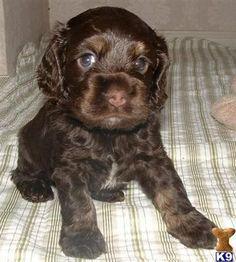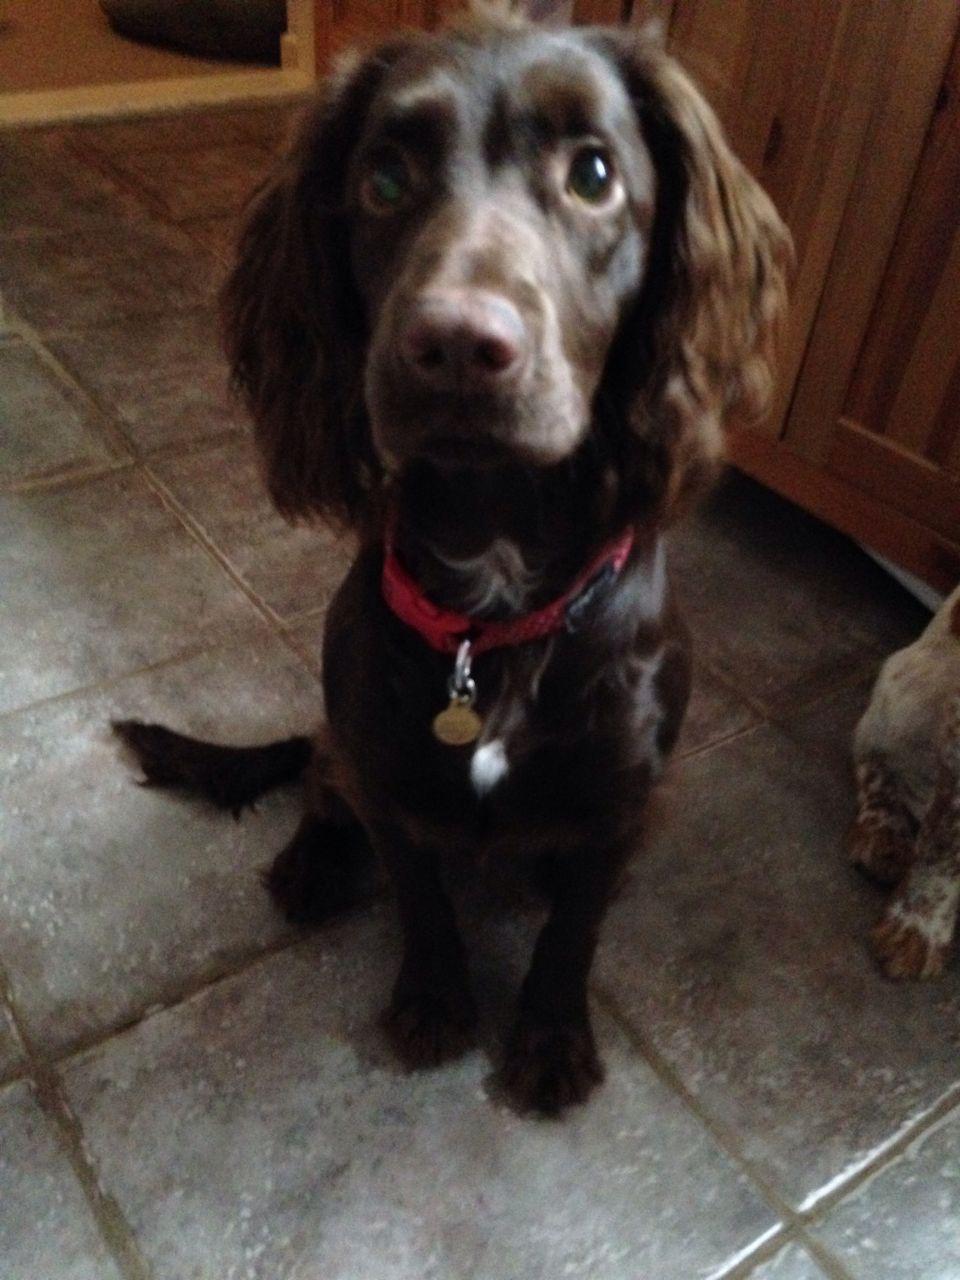The first image is the image on the left, the second image is the image on the right. Evaluate the accuracy of this statement regarding the images: "The left image features a very young chocolate-colored spaniel in a sitting position, and the right image features a bigger sitting spaniel.". Is it true? Answer yes or no. Yes. The first image is the image on the left, the second image is the image on the right. Assess this claim about the two images: "One dog is outside in one of the images.". Correct or not? Answer yes or no. No. 